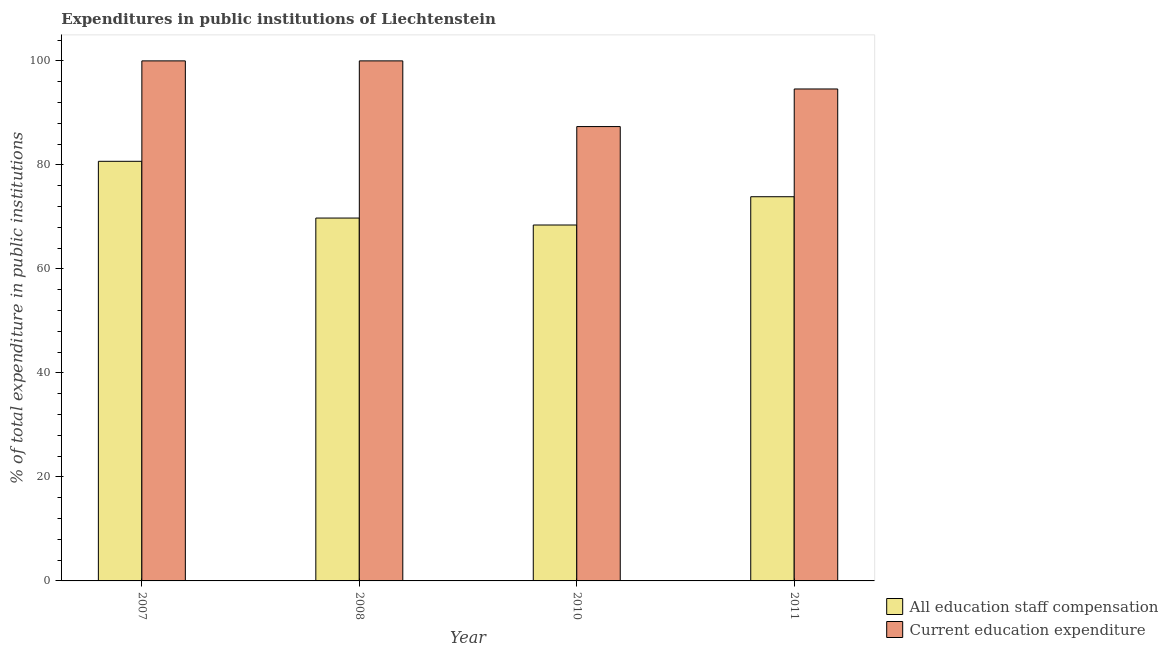How many groups of bars are there?
Your response must be concise. 4. Are the number of bars on each tick of the X-axis equal?
Offer a very short reply. Yes. How many bars are there on the 4th tick from the left?
Your response must be concise. 2. What is the label of the 2nd group of bars from the left?
Keep it short and to the point. 2008. What is the expenditure in staff compensation in 2011?
Offer a terse response. 73.88. Across all years, what is the maximum expenditure in staff compensation?
Make the answer very short. 80.69. Across all years, what is the minimum expenditure in education?
Your answer should be compact. 87.37. In which year was the expenditure in education maximum?
Your response must be concise. 2007. In which year was the expenditure in education minimum?
Make the answer very short. 2010. What is the total expenditure in education in the graph?
Provide a succinct answer. 381.97. What is the difference between the expenditure in education in 2008 and that in 2011?
Your answer should be compact. 5.4. What is the difference between the expenditure in staff compensation in 2008 and the expenditure in education in 2007?
Give a very brief answer. -10.92. What is the average expenditure in education per year?
Your answer should be compact. 95.49. In the year 2007, what is the difference between the expenditure in education and expenditure in staff compensation?
Provide a short and direct response. 0. What is the ratio of the expenditure in staff compensation in 2008 to that in 2010?
Your answer should be very brief. 1.02. Is the difference between the expenditure in education in 2010 and 2011 greater than the difference between the expenditure in staff compensation in 2010 and 2011?
Your response must be concise. No. What is the difference between the highest and the lowest expenditure in education?
Give a very brief answer. 12.63. In how many years, is the expenditure in education greater than the average expenditure in education taken over all years?
Provide a short and direct response. 2. Is the sum of the expenditure in staff compensation in 2010 and 2011 greater than the maximum expenditure in education across all years?
Ensure brevity in your answer.  Yes. What does the 1st bar from the left in 2007 represents?
Ensure brevity in your answer.  All education staff compensation. What does the 2nd bar from the right in 2011 represents?
Make the answer very short. All education staff compensation. Are all the bars in the graph horizontal?
Keep it short and to the point. No. What is the difference between two consecutive major ticks on the Y-axis?
Keep it short and to the point. 20. Are the values on the major ticks of Y-axis written in scientific E-notation?
Your answer should be very brief. No. Does the graph contain any zero values?
Your answer should be compact. No. Does the graph contain grids?
Offer a terse response. No. How many legend labels are there?
Give a very brief answer. 2. How are the legend labels stacked?
Keep it short and to the point. Vertical. What is the title of the graph?
Your answer should be compact. Expenditures in public institutions of Liechtenstein. What is the label or title of the Y-axis?
Provide a succinct answer. % of total expenditure in public institutions. What is the % of total expenditure in public institutions of All education staff compensation in 2007?
Provide a succinct answer. 80.69. What is the % of total expenditure in public institutions of All education staff compensation in 2008?
Offer a very short reply. 69.77. What is the % of total expenditure in public institutions in Current education expenditure in 2008?
Give a very brief answer. 100. What is the % of total expenditure in public institutions in All education staff compensation in 2010?
Your answer should be compact. 68.44. What is the % of total expenditure in public institutions in Current education expenditure in 2010?
Provide a short and direct response. 87.37. What is the % of total expenditure in public institutions of All education staff compensation in 2011?
Offer a terse response. 73.88. What is the % of total expenditure in public institutions in Current education expenditure in 2011?
Provide a short and direct response. 94.6. Across all years, what is the maximum % of total expenditure in public institutions of All education staff compensation?
Provide a short and direct response. 80.69. Across all years, what is the maximum % of total expenditure in public institutions in Current education expenditure?
Give a very brief answer. 100. Across all years, what is the minimum % of total expenditure in public institutions in All education staff compensation?
Offer a very short reply. 68.44. Across all years, what is the minimum % of total expenditure in public institutions of Current education expenditure?
Keep it short and to the point. 87.37. What is the total % of total expenditure in public institutions of All education staff compensation in the graph?
Provide a succinct answer. 292.78. What is the total % of total expenditure in public institutions of Current education expenditure in the graph?
Keep it short and to the point. 381.97. What is the difference between the % of total expenditure in public institutions of All education staff compensation in 2007 and that in 2008?
Keep it short and to the point. 10.92. What is the difference between the % of total expenditure in public institutions of All education staff compensation in 2007 and that in 2010?
Your response must be concise. 12.25. What is the difference between the % of total expenditure in public institutions of Current education expenditure in 2007 and that in 2010?
Keep it short and to the point. 12.63. What is the difference between the % of total expenditure in public institutions of All education staff compensation in 2007 and that in 2011?
Offer a very short reply. 6.81. What is the difference between the % of total expenditure in public institutions of Current education expenditure in 2007 and that in 2011?
Your answer should be compact. 5.4. What is the difference between the % of total expenditure in public institutions in All education staff compensation in 2008 and that in 2010?
Ensure brevity in your answer.  1.34. What is the difference between the % of total expenditure in public institutions of Current education expenditure in 2008 and that in 2010?
Offer a terse response. 12.63. What is the difference between the % of total expenditure in public institutions in All education staff compensation in 2008 and that in 2011?
Keep it short and to the point. -4.1. What is the difference between the % of total expenditure in public institutions in Current education expenditure in 2008 and that in 2011?
Your answer should be compact. 5.4. What is the difference between the % of total expenditure in public institutions of All education staff compensation in 2010 and that in 2011?
Offer a very short reply. -5.44. What is the difference between the % of total expenditure in public institutions of Current education expenditure in 2010 and that in 2011?
Keep it short and to the point. -7.23. What is the difference between the % of total expenditure in public institutions in All education staff compensation in 2007 and the % of total expenditure in public institutions in Current education expenditure in 2008?
Offer a terse response. -19.31. What is the difference between the % of total expenditure in public institutions in All education staff compensation in 2007 and the % of total expenditure in public institutions in Current education expenditure in 2010?
Your response must be concise. -6.68. What is the difference between the % of total expenditure in public institutions in All education staff compensation in 2007 and the % of total expenditure in public institutions in Current education expenditure in 2011?
Make the answer very short. -13.91. What is the difference between the % of total expenditure in public institutions in All education staff compensation in 2008 and the % of total expenditure in public institutions in Current education expenditure in 2010?
Offer a terse response. -17.59. What is the difference between the % of total expenditure in public institutions of All education staff compensation in 2008 and the % of total expenditure in public institutions of Current education expenditure in 2011?
Ensure brevity in your answer.  -24.82. What is the difference between the % of total expenditure in public institutions of All education staff compensation in 2010 and the % of total expenditure in public institutions of Current education expenditure in 2011?
Provide a succinct answer. -26.16. What is the average % of total expenditure in public institutions of All education staff compensation per year?
Offer a terse response. 73.2. What is the average % of total expenditure in public institutions in Current education expenditure per year?
Provide a succinct answer. 95.49. In the year 2007, what is the difference between the % of total expenditure in public institutions of All education staff compensation and % of total expenditure in public institutions of Current education expenditure?
Ensure brevity in your answer.  -19.31. In the year 2008, what is the difference between the % of total expenditure in public institutions in All education staff compensation and % of total expenditure in public institutions in Current education expenditure?
Your answer should be compact. -30.23. In the year 2010, what is the difference between the % of total expenditure in public institutions in All education staff compensation and % of total expenditure in public institutions in Current education expenditure?
Keep it short and to the point. -18.93. In the year 2011, what is the difference between the % of total expenditure in public institutions of All education staff compensation and % of total expenditure in public institutions of Current education expenditure?
Ensure brevity in your answer.  -20.72. What is the ratio of the % of total expenditure in public institutions in All education staff compensation in 2007 to that in 2008?
Your answer should be very brief. 1.16. What is the ratio of the % of total expenditure in public institutions of All education staff compensation in 2007 to that in 2010?
Provide a succinct answer. 1.18. What is the ratio of the % of total expenditure in public institutions in Current education expenditure in 2007 to that in 2010?
Your answer should be compact. 1.14. What is the ratio of the % of total expenditure in public institutions in All education staff compensation in 2007 to that in 2011?
Provide a succinct answer. 1.09. What is the ratio of the % of total expenditure in public institutions in Current education expenditure in 2007 to that in 2011?
Your response must be concise. 1.06. What is the ratio of the % of total expenditure in public institutions of All education staff compensation in 2008 to that in 2010?
Your answer should be very brief. 1.02. What is the ratio of the % of total expenditure in public institutions in Current education expenditure in 2008 to that in 2010?
Give a very brief answer. 1.14. What is the ratio of the % of total expenditure in public institutions in All education staff compensation in 2008 to that in 2011?
Your answer should be compact. 0.94. What is the ratio of the % of total expenditure in public institutions in Current education expenditure in 2008 to that in 2011?
Your answer should be very brief. 1.06. What is the ratio of the % of total expenditure in public institutions of All education staff compensation in 2010 to that in 2011?
Keep it short and to the point. 0.93. What is the ratio of the % of total expenditure in public institutions of Current education expenditure in 2010 to that in 2011?
Your response must be concise. 0.92. What is the difference between the highest and the second highest % of total expenditure in public institutions of All education staff compensation?
Your response must be concise. 6.81. What is the difference between the highest and the lowest % of total expenditure in public institutions in All education staff compensation?
Ensure brevity in your answer.  12.25. What is the difference between the highest and the lowest % of total expenditure in public institutions of Current education expenditure?
Your answer should be compact. 12.63. 